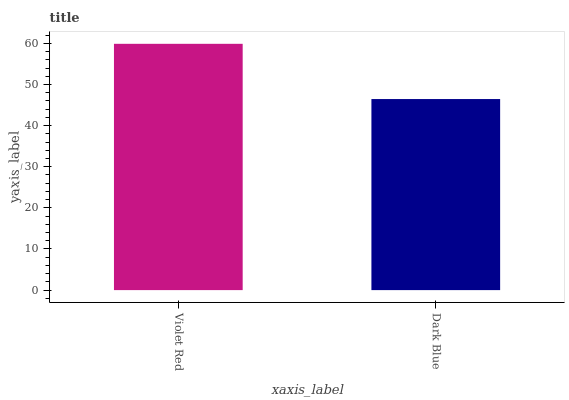Is Dark Blue the minimum?
Answer yes or no. Yes. Is Violet Red the maximum?
Answer yes or no. Yes. Is Dark Blue the maximum?
Answer yes or no. No. Is Violet Red greater than Dark Blue?
Answer yes or no. Yes. Is Dark Blue less than Violet Red?
Answer yes or no. Yes. Is Dark Blue greater than Violet Red?
Answer yes or no. No. Is Violet Red less than Dark Blue?
Answer yes or no. No. Is Violet Red the high median?
Answer yes or no. Yes. Is Dark Blue the low median?
Answer yes or no. Yes. Is Dark Blue the high median?
Answer yes or no. No. Is Violet Red the low median?
Answer yes or no. No. 